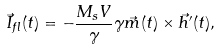Convert formula to latex. <formula><loc_0><loc_0><loc_500><loc_500>\vec { I } _ { f l } ( t ) = - \frac { M _ { s } V } { \gamma } \gamma \vec { m } ( t ) \times \vec { h } ^ { \prime } ( t ) ,</formula> 